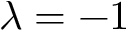<formula> <loc_0><loc_0><loc_500><loc_500>\lambda = - 1</formula> 